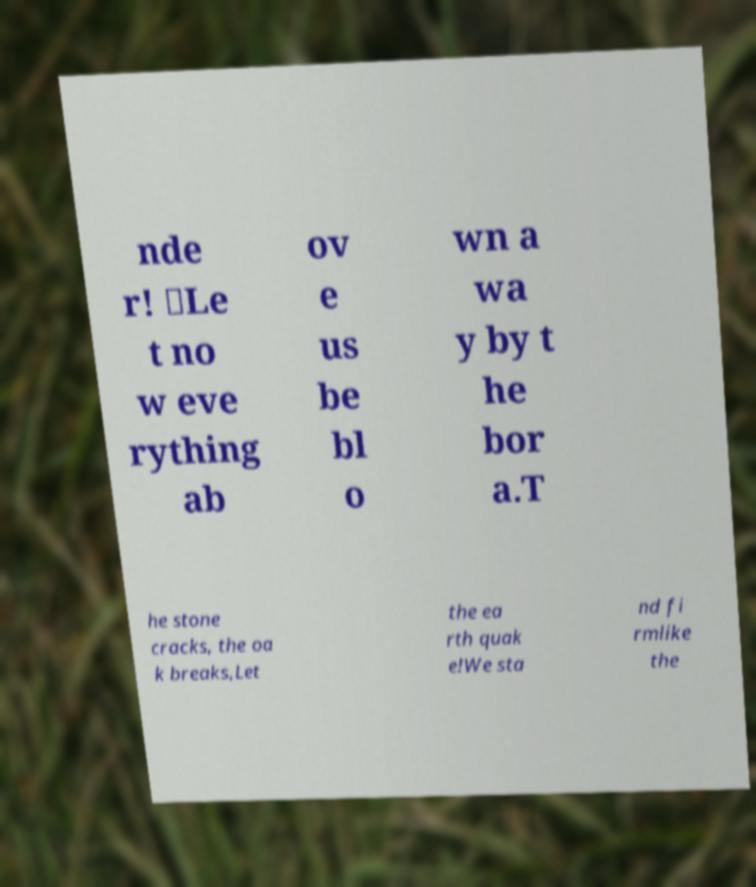Can you accurately transcribe the text from the provided image for me? nde r! 𝄇Le t no w eve rything ab ov e us be bl o wn a wa y by t he bor a.T he stone cracks, the oa k breaks,Let the ea rth quak e!We sta nd fi rmlike the 